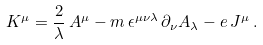Convert formula to latex. <formula><loc_0><loc_0><loc_500><loc_500>K ^ { \mu } = \frac { 2 } { \lambda } \, A ^ { \mu } - m \, \epsilon ^ { \mu \nu \lambda } \, \partial _ { \nu } A _ { \lambda } - e \, J ^ { \mu } \, .</formula> 